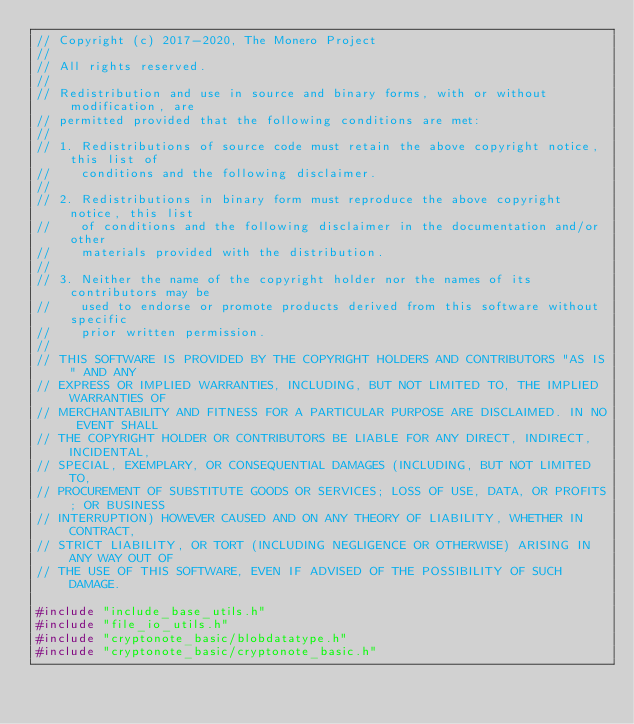Convert code to text. <code><loc_0><loc_0><loc_500><loc_500><_C++_>// Copyright (c) 2017-2020, The Monero Project
// 
// All rights reserved.
// 
// Redistribution and use in source and binary forms, with or without modification, are
// permitted provided that the following conditions are met:
// 
// 1. Redistributions of source code must retain the above copyright notice, this list of
//    conditions and the following disclaimer.
// 
// 2. Redistributions in binary form must reproduce the above copyright notice, this list
//    of conditions and the following disclaimer in the documentation and/or other
//    materials provided with the distribution.
// 
// 3. Neither the name of the copyright holder nor the names of its contributors may be
//    used to endorse or promote products derived from this software without specific
//    prior written permission.
// 
// THIS SOFTWARE IS PROVIDED BY THE COPYRIGHT HOLDERS AND CONTRIBUTORS "AS IS" AND ANY
// EXPRESS OR IMPLIED WARRANTIES, INCLUDING, BUT NOT LIMITED TO, THE IMPLIED WARRANTIES OF
// MERCHANTABILITY AND FITNESS FOR A PARTICULAR PURPOSE ARE DISCLAIMED. IN NO EVENT SHALL
// THE COPYRIGHT HOLDER OR CONTRIBUTORS BE LIABLE FOR ANY DIRECT, INDIRECT, INCIDENTAL,
// SPECIAL, EXEMPLARY, OR CONSEQUENTIAL DAMAGES (INCLUDING, BUT NOT LIMITED TO,
// PROCUREMENT OF SUBSTITUTE GOODS OR SERVICES; LOSS OF USE, DATA, OR PROFITS; OR BUSINESS
// INTERRUPTION) HOWEVER CAUSED AND ON ANY THEORY OF LIABILITY, WHETHER IN CONTRACT,
// STRICT LIABILITY, OR TORT (INCLUDING NEGLIGENCE OR OTHERWISE) ARISING IN ANY WAY OUT OF
// THE USE OF THIS SOFTWARE, EVEN IF ADVISED OF THE POSSIBILITY OF SUCH DAMAGE.

#include "include_base_utils.h"
#include "file_io_utils.h"
#include "cryptonote_basic/blobdatatype.h"
#include "cryptonote_basic/cryptonote_basic.h"</code> 